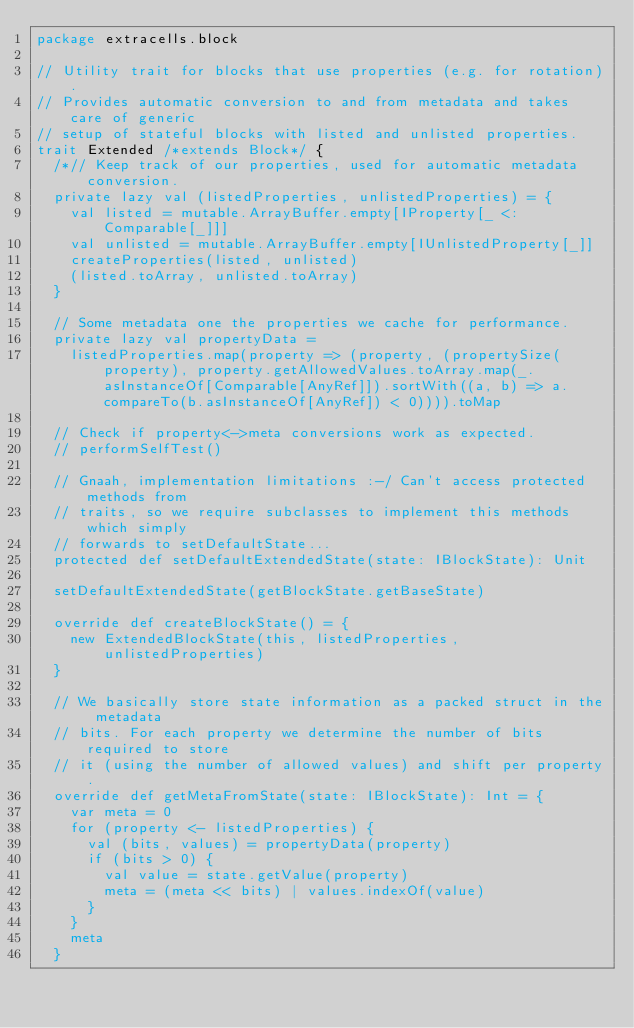<code> <loc_0><loc_0><loc_500><loc_500><_Scala_>package extracells.block

// Utility trait for blocks that use properties (e.g. for rotation).
// Provides automatic conversion to and from metadata and takes care of generic
// setup of stateful blocks with listed and unlisted properties.
trait Extended /*extends Block*/ {
  /*// Keep track of our properties, used for automatic metadata conversion.
  private lazy val (listedProperties, unlistedProperties) = {
    val listed = mutable.ArrayBuffer.empty[IProperty[_ <: Comparable[_]]]
    val unlisted = mutable.ArrayBuffer.empty[IUnlistedProperty[_]]
    createProperties(listed, unlisted)
    (listed.toArray, unlisted.toArray)
  }

  // Some metadata one the properties we cache for performance.
  private lazy val propertyData =
    listedProperties.map(property => (property, (propertySize(property), property.getAllowedValues.toArray.map(_.asInstanceOf[Comparable[AnyRef]]).sortWith((a, b) => a.compareTo(b.asInstanceOf[AnyRef]) < 0)))).toMap

  // Check if property<->meta conversions work as expected.
  // performSelfTest()

  // Gnaah, implementation limitations :-/ Can't access protected methods from
  // traits, so we require subclasses to implement this methods which simply
  // forwards to setDefaultState...
  protected def setDefaultExtendedState(state: IBlockState): Unit

  setDefaultExtendedState(getBlockState.getBaseState)

  override def createBlockState() = {
    new ExtendedBlockState(this, listedProperties, unlistedProperties)
  }

  // We basically store state information as a packed struct in the metadata
  // bits. For each property we determine the number of bits required to store
  // it (using the number of allowed values) and shift per property.
  override def getMetaFromState(state: IBlockState): Int = {
    var meta = 0
    for (property <- listedProperties) {
      val (bits, values) = propertyData(property)
      if (bits > 0) {
        val value = state.getValue(property)
        meta = (meta << bits) | values.indexOf(value)
      }
    }
    meta
  }
</code> 